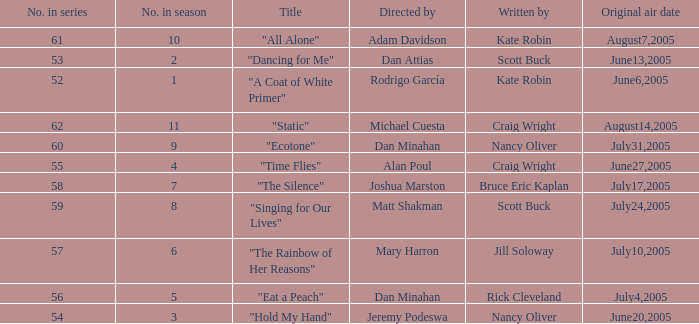What date was episode 10 in the season originally aired? August7,2005. 